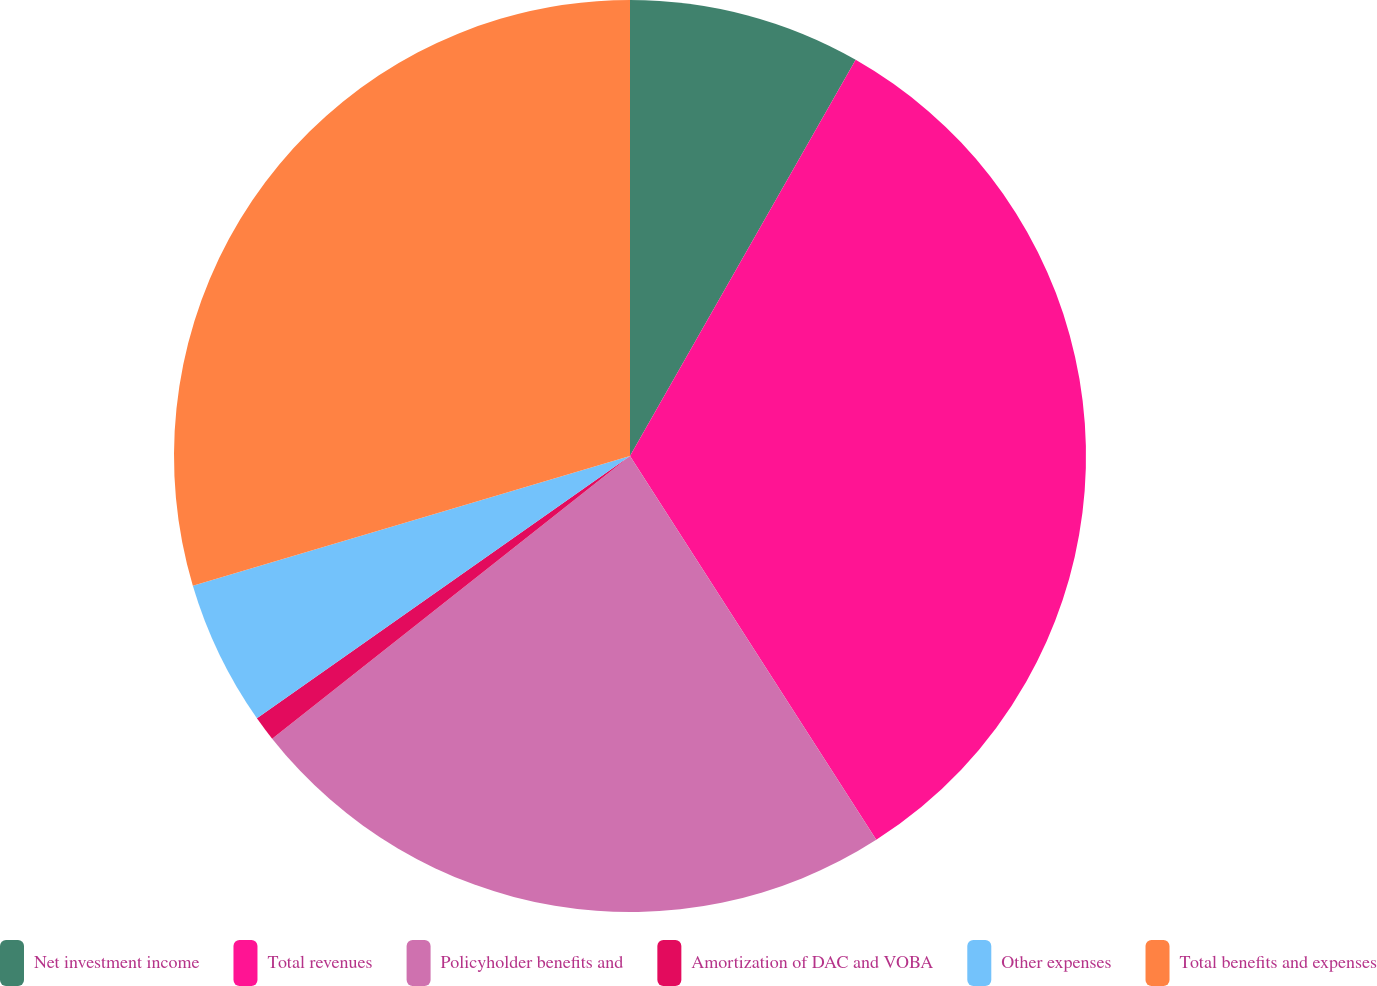<chart> <loc_0><loc_0><loc_500><loc_500><pie_chart><fcel>Net investment income<fcel>Total revenues<fcel>Policyholder benefits and<fcel>Amortization of DAC and VOBA<fcel>Other expenses<fcel>Total benefits and expenses<nl><fcel>8.24%<fcel>32.68%<fcel>23.44%<fcel>0.89%<fcel>5.16%<fcel>29.59%<nl></chart> 